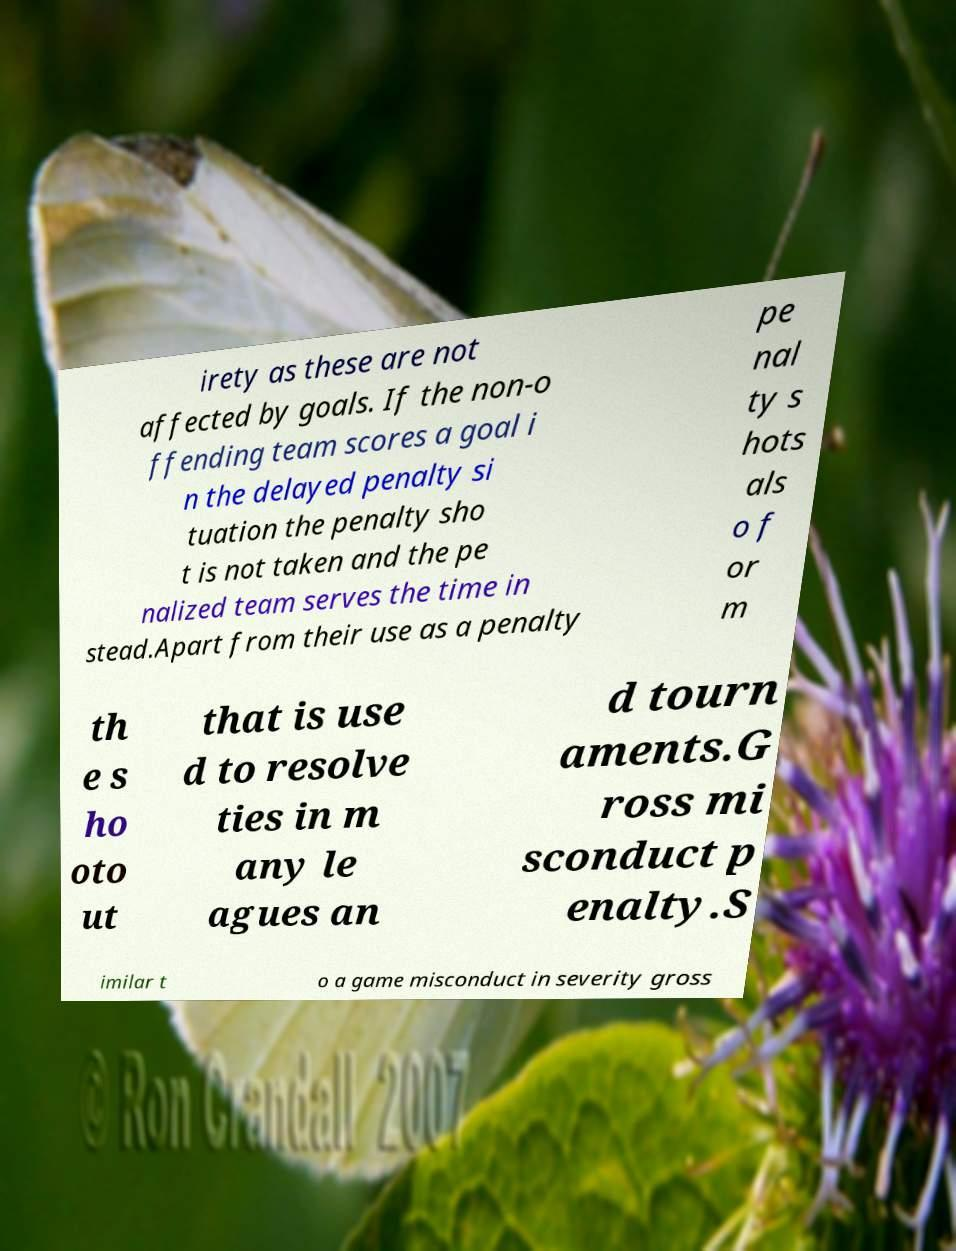I need the written content from this picture converted into text. Can you do that? irety as these are not affected by goals. If the non-o ffending team scores a goal i n the delayed penalty si tuation the penalty sho t is not taken and the pe nalized team serves the time in stead.Apart from their use as a penalty pe nal ty s hots als o f or m th e s ho oto ut that is use d to resolve ties in m any le agues an d tourn aments.G ross mi sconduct p enalty.S imilar t o a game misconduct in severity gross 